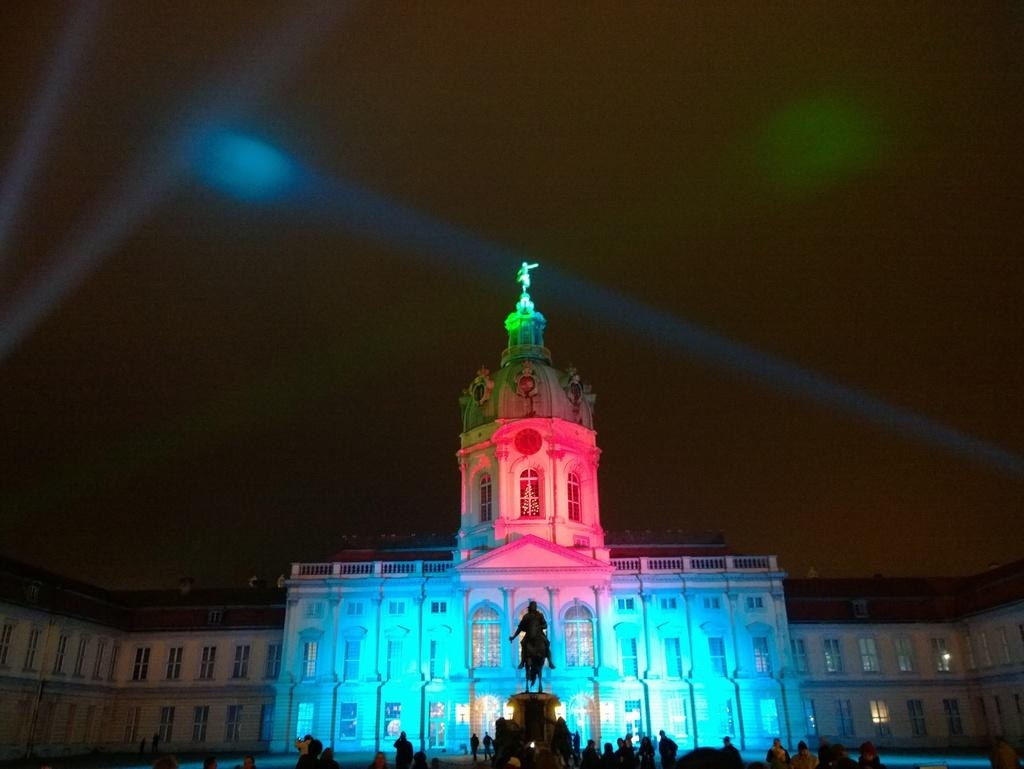What type of building is in the image? There is a palace in the image. Who or what is present at the bottom of the image? There are people at the bottom of the image. What other object can be seen in the image besides the palace? There is a statue in the image. What can be seen in the background of the image? The sky is visible in the background of the image. Are there any artificial light sources in the image? Yes, there are lights in the image. What type of religion is practiced in the harbor depicted in the image? There is no harbor present in the image, so it is not possible to determine what type of religion might be practiced there. 